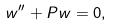<formula> <loc_0><loc_0><loc_500><loc_500>w ^ { \prime \prime } + P w = 0 ,</formula> 